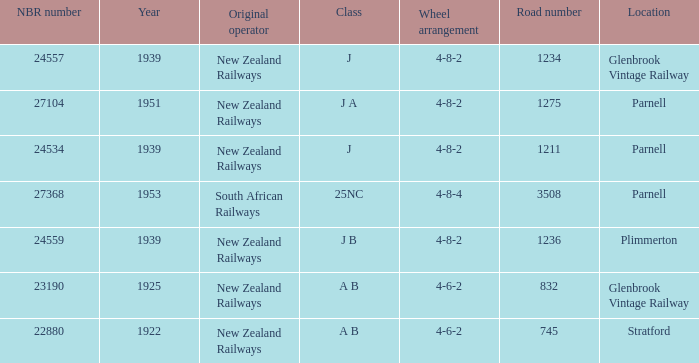Which class starts after 1939 and has a road number smaller than 3508? J A. 